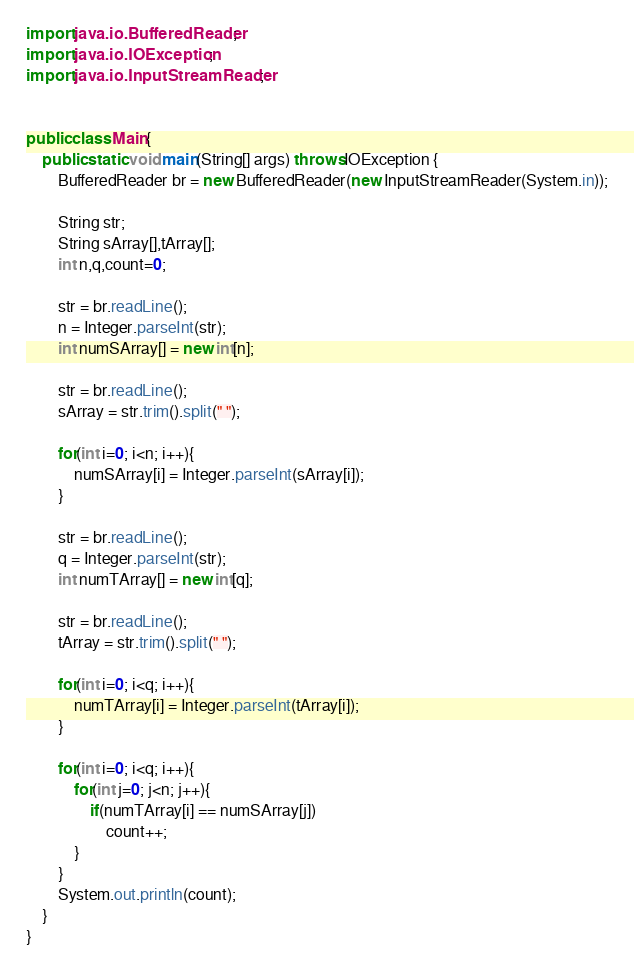Convert code to text. <code><loc_0><loc_0><loc_500><loc_500><_Java_>import java.io.BufferedReader;
import java.io.IOException;
import java.io.InputStreamReader;


public class Main{
	public static void main(String[] args) throws IOException {
		BufferedReader br = new BufferedReader(new InputStreamReader(System.in));

		String str;
		String sArray[],tArray[];
		int n,q,count=0;

		str = br.readLine();
		n = Integer.parseInt(str);
		int numSArray[] = new int[n];

		str = br.readLine();
		sArray = str.trim().split(" ");

		for(int i=0; i<n; i++){
			numSArray[i] = Integer.parseInt(sArray[i]);
		}

		str = br.readLine();
		q = Integer.parseInt(str);
		int numTArray[] = new int[q];

		str = br.readLine();
		tArray = str.trim().split(" ");

		for(int i=0; i<q; i++){
			numTArray[i] = Integer.parseInt(tArray[i]);
		}

		for(int i=0; i<q; i++){
			for(int j=0; j<n; j++){
				if(numTArray[i] == numSArray[j])
					count++;
			}
		}
		System.out.println(count);
	}
}</code> 